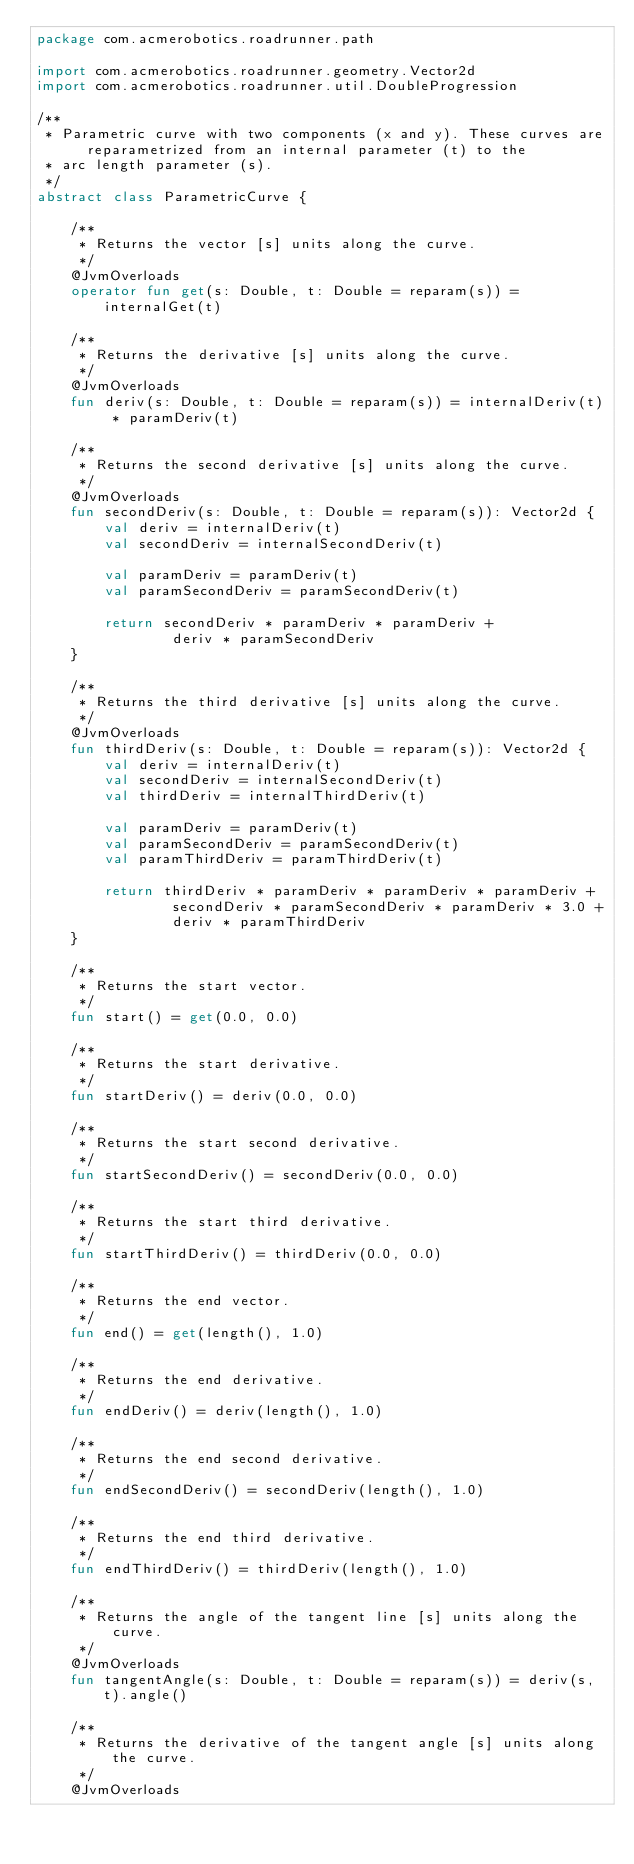<code> <loc_0><loc_0><loc_500><loc_500><_Kotlin_>package com.acmerobotics.roadrunner.path

import com.acmerobotics.roadrunner.geometry.Vector2d
import com.acmerobotics.roadrunner.util.DoubleProgression

/**
 * Parametric curve with two components (x and y). These curves are reparametrized from an internal parameter (t) to the
 * arc length parameter (s).
 */
abstract class ParametricCurve {

    /**
     * Returns the vector [s] units along the curve.
     */
    @JvmOverloads
    operator fun get(s: Double, t: Double = reparam(s)) = internalGet(t)

    /**
     * Returns the derivative [s] units along the curve.
     */
    @JvmOverloads
    fun deriv(s: Double, t: Double = reparam(s)) = internalDeriv(t) * paramDeriv(t)

    /**
     * Returns the second derivative [s] units along the curve.
     */
    @JvmOverloads
    fun secondDeriv(s: Double, t: Double = reparam(s)): Vector2d {
        val deriv = internalDeriv(t)
        val secondDeriv = internalSecondDeriv(t)

        val paramDeriv = paramDeriv(t)
        val paramSecondDeriv = paramSecondDeriv(t)

        return secondDeriv * paramDeriv * paramDeriv +
                deriv * paramSecondDeriv
    }

    /**
     * Returns the third derivative [s] units along the curve.
     */
    @JvmOverloads
    fun thirdDeriv(s: Double, t: Double = reparam(s)): Vector2d {
        val deriv = internalDeriv(t)
        val secondDeriv = internalSecondDeriv(t)
        val thirdDeriv = internalThirdDeriv(t)

        val paramDeriv = paramDeriv(t)
        val paramSecondDeriv = paramSecondDeriv(t)
        val paramThirdDeriv = paramThirdDeriv(t)

        return thirdDeriv * paramDeriv * paramDeriv * paramDeriv +
                secondDeriv * paramSecondDeriv * paramDeriv * 3.0 +
                deriv * paramThirdDeriv
    }

    /**
     * Returns the start vector.
     */
    fun start() = get(0.0, 0.0)

    /**
     * Returns the start derivative.
     */
    fun startDeriv() = deriv(0.0, 0.0)

    /**
     * Returns the start second derivative.
     */
    fun startSecondDeriv() = secondDeriv(0.0, 0.0)

    /**
     * Returns the start third derivative.
     */
    fun startThirdDeriv() = thirdDeriv(0.0, 0.0)

    /**
     * Returns the end vector.
     */
    fun end() = get(length(), 1.0)

    /**
     * Returns the end derivative.
     */
    fun endDeriv() = deriv(length(), 1.0)

    /**
     * Returns the end second derivative.
     */
    fun endSecondDeriv() = secondDeriv(length(), 1.0)

    /**
     * Returns the end third derivative.
     */
    fun endThirdDeriv() = thirdDeriv(length(), 1.0)

    /**
     * Returns the angle of the tangent line [s] units along the curve.
     */
    @JvmOverloads
    fun tangentAngle(s: Double, t: Double = reparam(s)) = deriv(s, t).angle()

    /**
     * Returns the derivative of the tangent angle [s] units along the curve.
     */
    @JvmOverloads</code> 